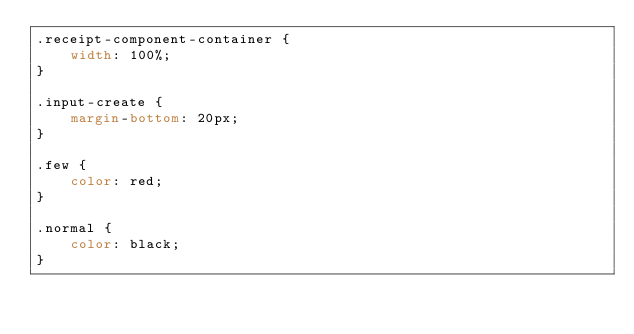Convert code to text. <code><loc_0><loc_0><loc_500><loc_500><_CSS_>.receipt-component-container {
    width: 100%;
}

.input-create {
    margin-bottom: 20px;
}

.few {
    color: red;
}

.normal {
    color: black;
}</code> 